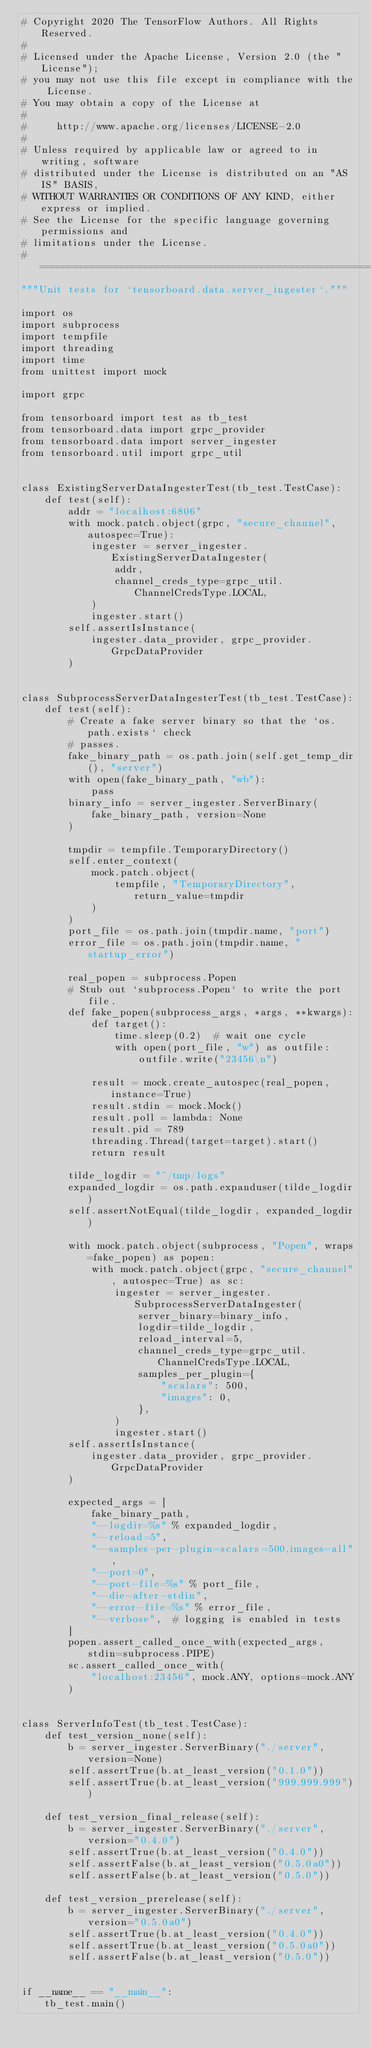Convert code to text. <code><loc_0><loc_0><loc_500><loc_500><_Python_># Copyright 2020 The TensorFlow Authors. All Rights Reserved.
#
# Licensed under the Apache License, Version 2.0 (the "License");
# you may not use this file except in compliance with the License.
# You may obtain a copy of the License at
#
#     http://www.apache.org/licenses/LICENSE-2.0
#
# Unless required by applicable law or agreed to in writing, software
# distributed under the License is distributed on an "AS IS" BASIS,
# WITHOUT WARRANTIES OR CONDITIONS OF ANY KIND, either express or implied.
# See the License for the specific language governing permissions and
# limitations under the License.
# ==============================================================================
"""Unit tests for `tensorboard.data.server_ingester`."""

import os
import subprocess
import tempfile
import threading
import time
from unittest import mock

import grpc

from tensorboard import test as tb_test
from tensorboard.data import grpc_provider
from tensorboard.data import server_ingester
from tensorboard.util import grpc_util


class ExistingServerDataIngesterTest(tb_test.TestCase):
    def test(self):
        addr = "localhost:6806"
        with mock.patch.object(grpc, "secure_channel", autospec=True):
            ingester = server_ingester.ExistingServerDataIngester(
                addr,
                channel_creds_type=grpc_util.ChannelCredsType.LOCAL,
            )
            ingester.start()
        self.assertIsInstance(
            ingester.data_provider, grpc_provider.GrpcDataProvider
        )


class SubprocessServerDataIngesterTest(tb_test.TestCase):
    def test(self):
        # Create a fake server binary so that the `os.path.exists` check
        # passes.
        fake_binary_path = os.path.join(self.get_temp_dir(), "server")
        with open(fake_binary_path, "wb"):
            pass
        binary_info = server_ingester.ServerBinary(
            fake_binary_path, version=None
        )

        tmpdir = tempfile.TemporaryDirectory()
        self.enter_context(
            mock.patch.object(
                tempfile, "TemporaryDirectory", return_value=tmpdir
            )
        )
        port_file = os.path.join(tmpdir.name, "port")
        error_file = os.path.join(tmpdir.name, "startup_error")

        real_popen = subprocess.Popen
        # Stub out `subprocess.Popen` to write the port file.
        def fake_popen(subprocess_args, *args, **kwargs):
            def target():
                time.sleep(0.2)  # wait one cycle
                with open(port_file, "w") as outfile:
                    outfile.write("23456\n")

            result = mock.create_autospec(real_popen, instance=True)
            result.stdin = mock.Mock()
            result.poll = lambda: None
            result.pid = 789
            threading.Thread(target=target).start()
            return result

        tilde_logdir = "~/tmp/logs"
        expanded_logdir = os.path.expanduser(tilde_logdir)
        self.assertNotEqual(tilde_logdir, expanded_logdir)

        with mock.patch.object(subprocess, "Popen", wraps=fake_popen) as popen:
            with mock.patch.object(grpc, "secure_channel", autospec=True) as sc:
                ingester = server_ingester.SubprocessServerDataIngester(
                    server_binary=binary_info,
                    logdir=tilde_logdir,
                    reload_interval=5,
                    channel_creds_type=grpc_util.ChannelCredsType.LOCAL,
                    samples_per_plugin={
                        "scalars": 500,
                        "images": 0,
                    },
                )
                ingester.start()
        self.assertIsInstance(
            ingester.data_provider, grpc_provider.GrpcDataProvider
        )

        expected_args = [
            fake_binary_path,
            "--logdir=%s" % expanded_logdir,
            "--reload=5",
            "--samples-per-plugin=scalars=500,images=all",
            "--port=0",
            "--port-file=%s" % port_file,
            "--die-after-stdin",
            "--error-file=%s" % error_file,
            "--verbose",  # logging is enabled in tests
        ]
        popen.assert_called_once_with(expected_args, stdin=subprocess.PIPE)
        sc.assert_called_once_with(
            "localhost:23456", mock.ANY, options=mock.ANY
        )


class ServerInfoTest(tb_test.TestCase):
    def test_version_none(self):
        b = server_ingester.ServerBinary("./server", version=None)
        self.assertTrue(b.at_least_version("0.1.0"))
        self.assertTrue(b.at_least_version("999.999.999"))

    def test_version_final_release(self):
        b = server_ingester.ServerBinary("./server", version="0.4.0")
        self.assertTrue(b.at_least_version("0.4.0"))
        self.assertFalse(b.at_least_version("0.5.0a0"))
        self.assertFalse(b.at_least_version("0.5.0"))

    def test_version_prerelease(self):
        b = server_ingester.ServerBinary("./server", version="0.5.0a0")
        self.assertTrue(b.at_least_version("0.4.0"))
        self.assertTrue(b.at_least_version("0.5.0a0"))
        self.assertFalse(b.at_least_version("0.5.0"))


if __name__ == "__main__":
    tb_test.main()
</code> 